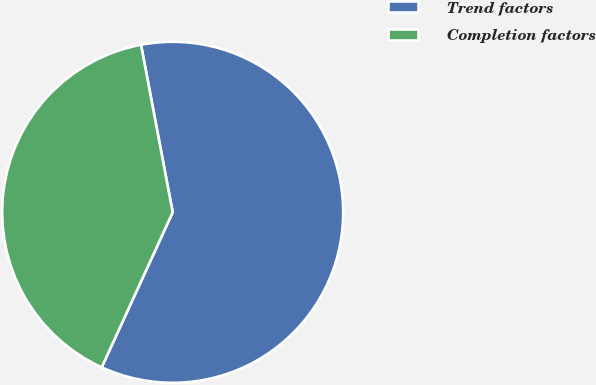Convert chart. <chart><loc_0><loc_0><loc_500><loc_500><pie_chart><fcel>Trend factors<fcel>Completion factors<nl><fcel>59.81%<fcel>40.19%<nl></chart> 